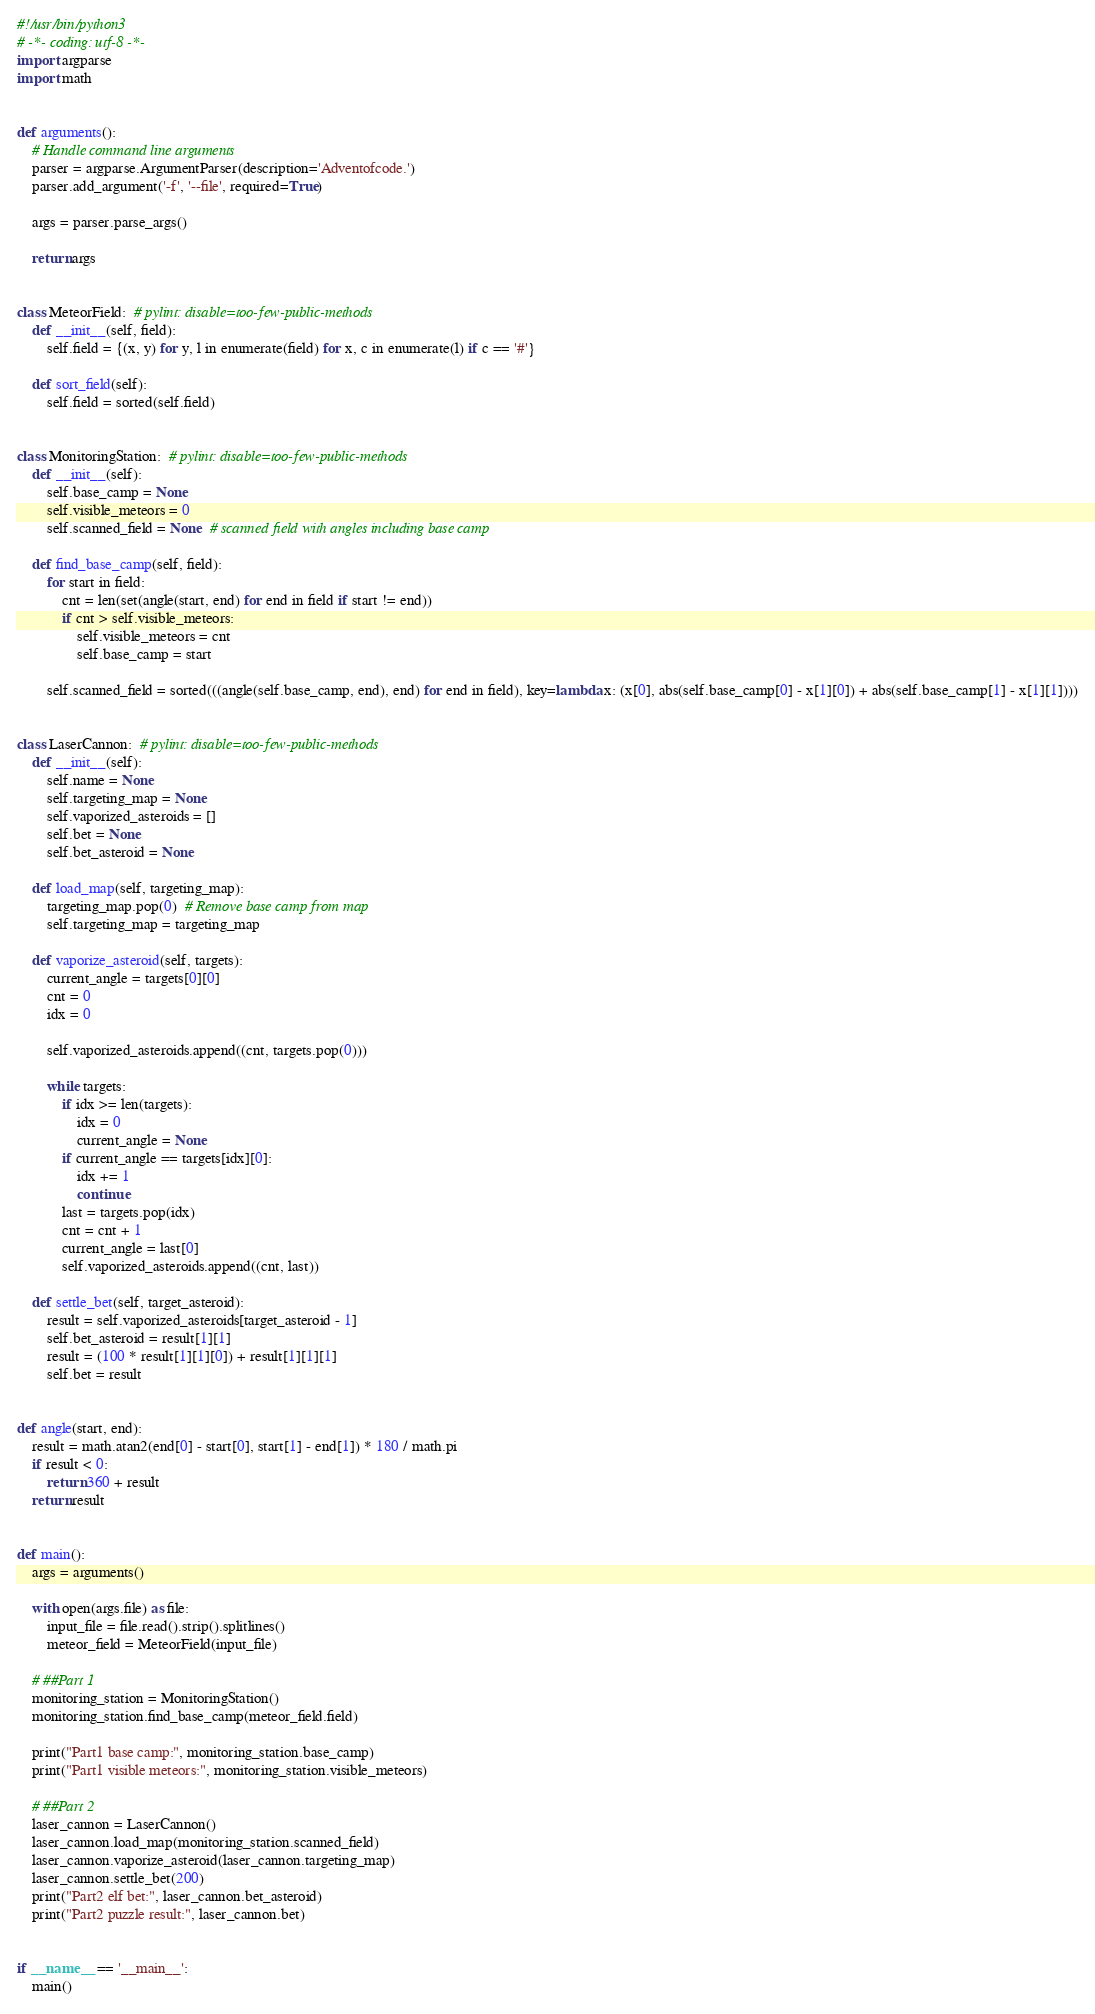<code> <loc_0><loc_0><loc_500><loc_500><_Python_>#!/usr/bin/python3
# -*- coding: utf-8 -*-
import argparse
import math


def arguments():
    # Handle command line arguments
    parser = argparse.ArgumentParser(description='Adventofcode.')
    parser.add_argument('-f', '--file', required=True)

    args = parser.parse_args()

    return args


class MeteorField:  # pylint: disable=too-few-public-methods
    def __init__(self, field):
        self.field = {(x, y) for y, l in enumerate(field) for x, c in enumerate(l) if c == '#'}

    def sort_field(self):
        self.field = sorted(self.field)


class MonitoringStation:  # pylint: disable=too-few-public-methods
    def __init__(self):
        self.base_camp = None
        self.visible_meteors = 0
        self.scanned_field = None  # scanned field with angles including base camp

    def find_base_camp(self, field):
        for start in field:
            cnt = len(set(angle(start, end) for end in field if start != end))
            if cnt > self.visible_meteors:
                self.visible_meteors = cnt
                self.base_camp = start

        self.scanned_field = sorted(((angle(self.base_camp, end), end) for end in field), key=lambda x: (x[0], abs(self.base_camp[0] - x[1][0]) + abs(self.base_camp[1] - x[1][1])))


class LaserCannon:  # pylint: disable=too-few-public-methods
    def __init__(self):
        self.name = None
        self.targeting_map = None
        self.vaporized_asteroids = []
        self.bet = None
        self.bet_asteroid = None

    def load_map(self, targeting_map):
        targeting_map.pop(0)  # Remove base camp from map
        self.targeting_map = targeting_map

    def vaporize_asteroid(self, targets):
        current_angle = targets[0][0]
        cnt = 0
        idx = 0

        self.vaporized_asteroids.append((cnt, targets.pop(0)))

        while targets:
            if idx >= len(targets):
                idx = 0
                current_angle = None
            if current_angle == targets[idx][0]:
                idx += 1
                continue
            last = targets.pop(idx)
            cnt = cnt + 1
            current_angle = last[0]
            self.vaporized_asteroids.append((cnt, last))

    def settle_bet(self, target_asteroid):
        result = self.vaporized_asteroids[target_asteroid - 1]
        self.bet_asteroid = result[1][1]
        result = (100 * result[1][1][0]) + result[1][1][1]
        self.bet = result


def angle(start, end):
    result = math.atan2(end[0] - start[0], start[1] - end[1]) * 180 / math.pi
    if result < 0:
        return 360 + result
    return result


def main():
    args = arguments()

    with open(args.file) as file:
        input_file = file.read().strip().splitlines()
        meteor_field = MeteorField(input_file)

    # ##Part 1
    monitoring_station = MonitoringStation()
    monitoring_station.find_base_camp(meteor_field.field)

    print("Part1 base camp:", monitoring_station.base_camp)
    print("Part1 visible meteors:", monitoring_station.visible_meteors)

    # ##Part 2
    laser_cannon = LaserCannon()
    laser_cannon.load_map(monitoring_station.scanned_field)
    laser_cannon.vaporize_asteroid(laser_cannon.targeting_map)
    laser_cannon.settle_bet(200)
    print("Part2 elf bet:", laser_cannon.bet_asteroid)
    print("Part2 puzzle result:", laser_cannon.bet)


if __name__ == '__main__':
    main()
</code> 